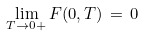Convert formula to latex. <formula><loc_0><loc_0><loc_500><loc_500>\lim _ { T \to 0 + } F ( 0 , T ) \, = \, 0</formula> 